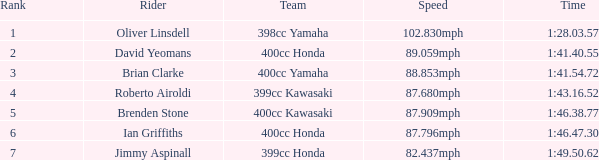What is the rank of the rider with time of 1:41.40.55? 2.0. 